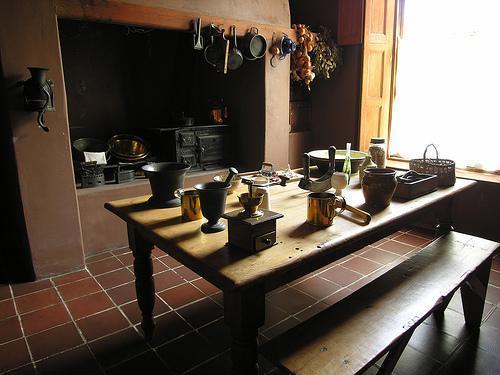How many benches?
Give a very brief answer. 1. How many windows?
Give a very brief answer. 1. 